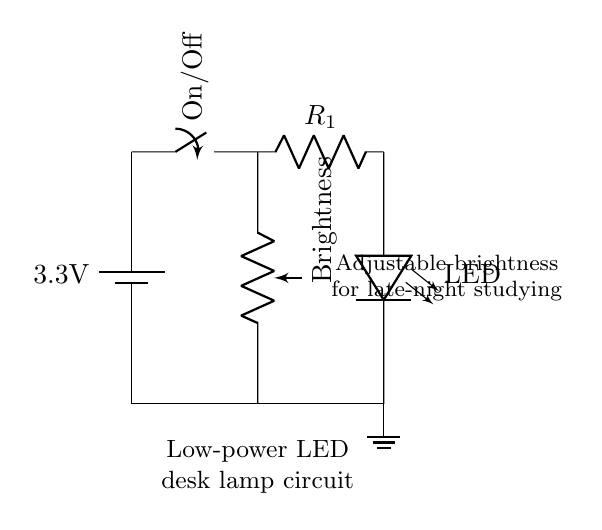What is the voltage of this circuit? The voltage of the circuit is 3.3 volts, as indicated by the battery symbol labeled with this value.
Answer: 3.3 volts What component is used for brightness control? The component used for brightness control is a potentiometer, indicated in the diagram as the component labeled "Brightness." It allows for variable resistance, leading to adjustable brightness of the LED.
Answer: Potentiometer How many main active components are in this circuit? The circuit has three main active components: the battery, the potentiometer, and the LED. Each plays a crucial role in the operation of the lamp; the battery provides power, the potentiometer adjusts brightness, and the LED emits light.
Answer: Three What does the current limiting resistor do? The current limiting resistor, labeled as R1, is essential as it prevents too much current from flowing through the LED, thereby protecting it from damage and helping to regulate its brightness.
Answer: Protects LED If the potentiometer is set to its maximum resistance, what happens to the brightness of the LED? When the potentiometer is at maximum resistance, it allows less current to flow through the circuit, resulting in reduced brightness of the LED. This is because with higher resistance, less voltage is dropped across the LED, leading to dimmer light output.
Answer: Reduced brightness What is the purpose of the switch in the circuit? The switch allows the user to turn the lamp on or off. When the switch is in the "On" position, current can flow through the circuit; when it is "Off," the circuit is open, and no current flows, turning off the lamp.
Answer: On/Off control What type of load does this circuit use? The circuit uses a resistive load in the form of an LED, which converts electrical energy into light. This is typical for low-power appliances designed for energy efficiency.
Answer: LED load 